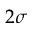Convert formula to latex. <formula><loc_0><loc_0><loc_500><loc_500>2 \sigma</formula> 